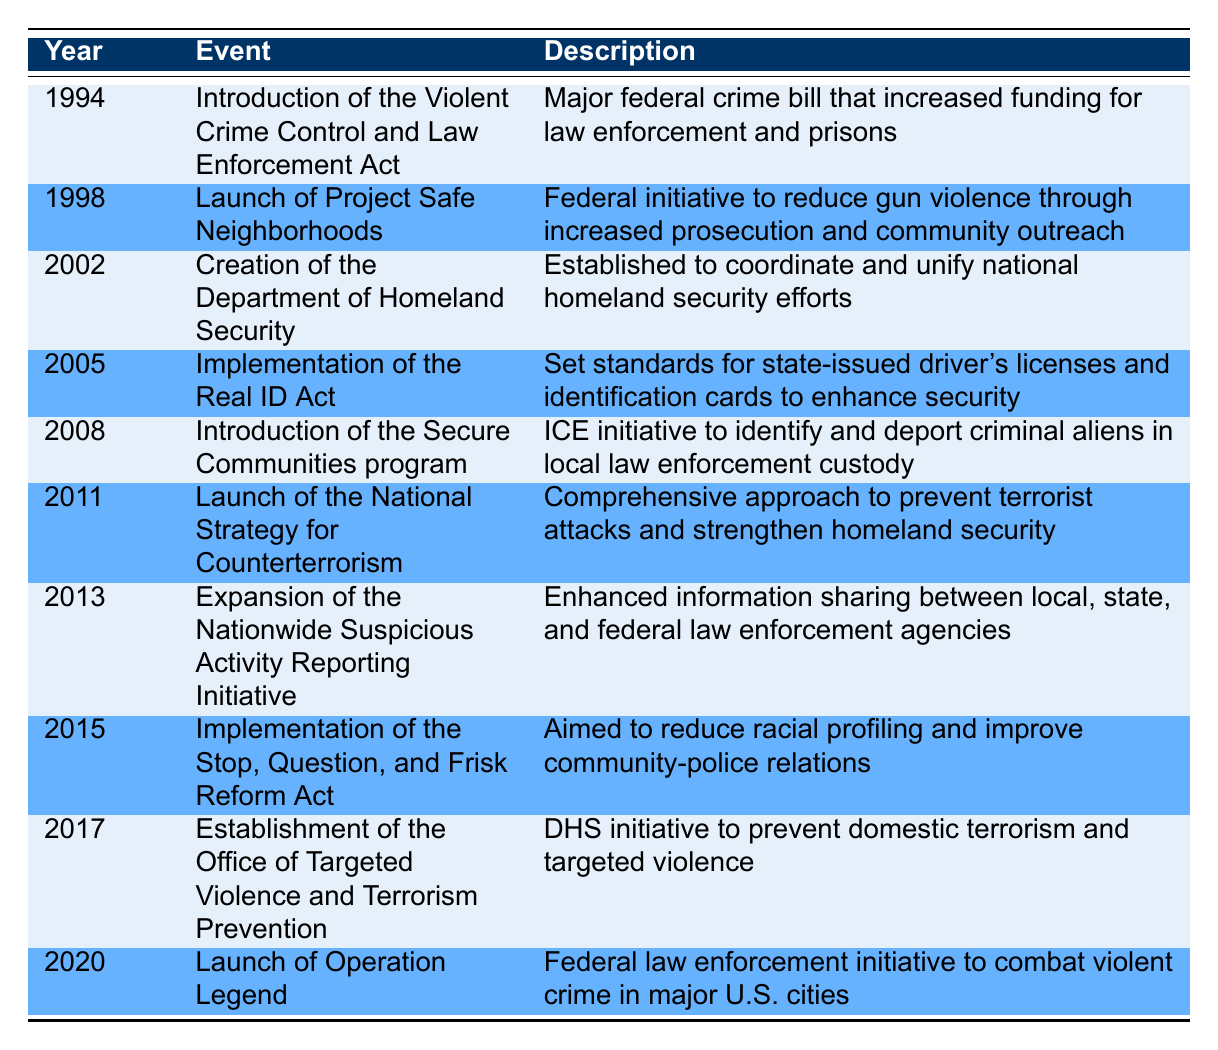What event was introduced in 1994? The table indicates that the event introduced in 1994 is the "Introduction of the Violent Crime Control and Law Enforcement Act." This can be directly retrieved from the first row of the table.
Answer: Introduction of the Violent Crime Control and Law Enforcement Act Which two events were launched in 2011 and 2013? From the table, the event launched in 2011 is the "Launch of the National Strategy for Counterterrorism," and in 2013 it is the "Expansion of the Nationwide Suspicious Activity Reporting Initiative." Both events can be found in the respective rows 2011 and 2013.
Answer: Launch of the National Strategy for Counterterrorism and Expansion of the Nationwide Suspicious Activity Reporting Initiative How many years are there between the introduction of the Real ID Act and the establishment of the Office of Targeted Violence and Terrorism Prevention? The Real ID Act was implemented in 2005 and the Office of Targeted Violence and Terrorism Prevention was established in 2017. The difference in years is 2017 - 2005, which equals 12 years.
Answer: 12 years Was the Secure Communities program introduced before the creation of the Department of Homeland Security? The Secure Communities program was introduced in 2008, whereas the Department of Homeland Security was created in 2002. Since 2008 comes after 2002, the statement is false.
Answer: No What is the average year for the milestones listed in the table? To find the average year, sum the years (1994 + 1998 + 2002 + 2005 + 2008 + 2011 + 2013 + 2015 + 2017 + 2020 = 2010). There are 10 data points, so divide the total (2010) by 10 to get the average year: 2010/10 = 2010.
Answer: 2010 Which event was aimed specifically to reduce racial profiling? The event aimed specifically to reduce racial profiling is the "Implementation of the Stop, Question, and Frisk Reform Act," which appears in 2015. This can be found directly in the corresponding row.
Answer: Implementation of the Stop, Question, and Frisk Reform Act In what year was the program aimed at combating violent crime in major U.S. cities launched? According to the table, "Operation Legend" was launched in 2020 as the initiative to combat violent crime in major U.S. cities, which is shown in the last row.
Answer: 2020 How many initiatives focus on community safety and outreach? The table lists "Launch of Project Safe Neighborhoods" (1998) and "Implementation of the Stop, Question, and Frisk Reform Act" (2015) as initiatives focusing on community safety and outreach. Adding these gives a total of 2 such initiatives.
Answer: 2 